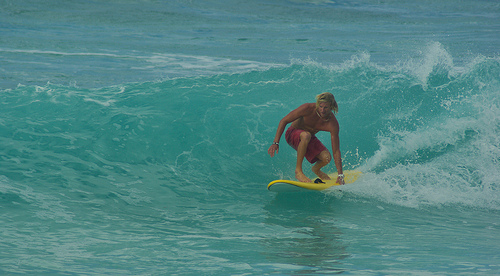Does the hair look blond? Yes, the hair of the surfer appears to be blond, shining brightly in the sunlight. 